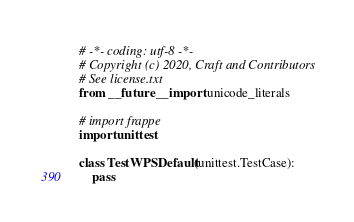Convert code to text. <code><loc_0><loc_0><loc_500><loc_500><_Python_># -*- coding: utf-8 -*-
# Copyright (c) 2020, Craft and Contributors
# See license.txt
from __future__ import unicode_literals

# import frappe
import unittest

class TestWPSDefault(unittest.TestCase):
	pass
</code> 